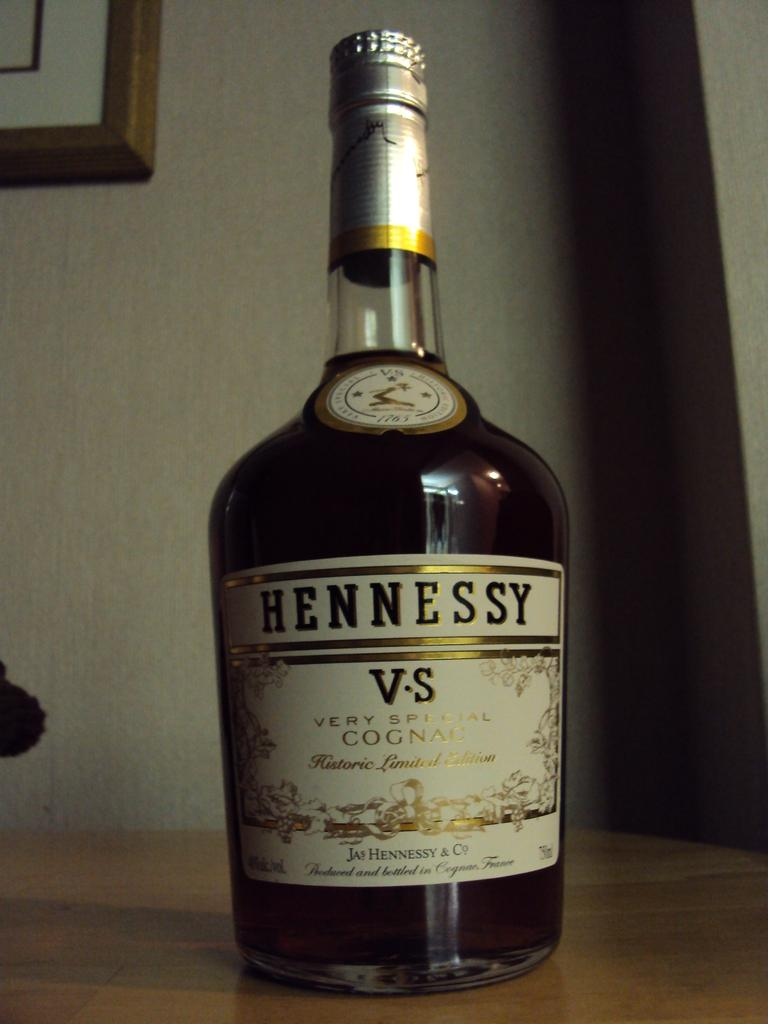<image>
Offer a succinct explanation of the picture presented. a Hennessy bottle that has alcohol in it 